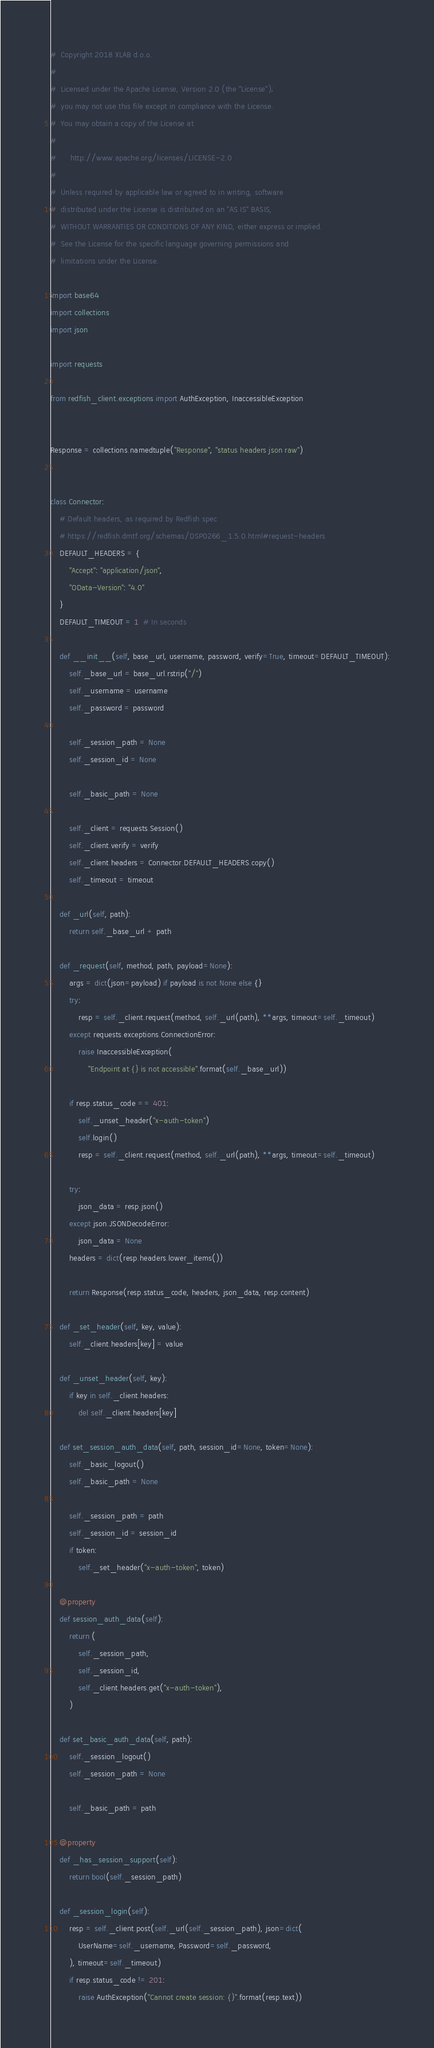<code> <loc_0><loc_0><loc_500><loc_500><_Python_>#  Copyright 2018 XLAB d.o.o.
#
#  Licensed under the Apache License, Version 2.0 (the "License");
#  you may not use this file except in compliance with the License.
#  You may obtain a copy of the License at
#
#      http://www.apache.org/licenses/LICENSE-2.0
#
#  Unless required by applicable law or agreed to in writing, software
#  distributed under the License is distributed on an "AS IS" BASIS,
#  WITHOUT WARRANTIES OR CONDITIONS OF ANY KIND, either express or implied.
#  See the License for the specific language governing permissions and
#  limitations under the License.

import base64
import collections
import json

import requests

from redfish_client.exceptions import AuthException, InaccessibleException


Response = collections.namedtuple("Response", "status headers json raw")


class Connector:
    # Default headers, as required by Redfish spec
    # https://redfish.dmtf.org/schemas/DSP0266_1.5.0.html#request-headers
    DEFAULT_HEADERS = {
        "Accept": "application/json",
        "OData-Version": "4.0"
    }
    DEFAULT_TIMEOUT = 1  # In seconds

    def __init__(self, base_url, username, password, verify=True, timeout=DEFAULT_TIMEOUT):
        self._base_url = base_url.rstrip("/")
        self._username = username
        self._password = password

        self._session_path = None
        self._session_id = None

        self._basic_path = None

        self._client = requests.Session()
        self._client.verify = verify
        self._client.headers = Connector.DEFAULT_HEADERS.copy()
        self._timeout = timeout

    def _url(self, path):
        return self._base_url + path

    def _request(self, method, path, payload=None):
        args = dict(json=payload) if payload is not None else {}
        try:
            resp = self._client.request(method, self._url(path), **args, timeout=self._timeout)
        except requests.exceptions.ConnectionError:
            raise InaccessibleException(
                "Endpoint at {} is not accessible".format(self._base_url))

        if resp.status_code == 401:
            self._unset_header("x-auth-token")
            self.login()
            resp = self._client.request(method, self._url(path), **args, timeout=self._timeout)

        try:
            json_data = resp.json()
        except json.JSONDecodeError:
            json_data = None
        headers = dict(resp.headers.lower_items())

        return Response(resp.status_code, headers, json_data, resp.content)

    def _set_header(self, key, value):
        self._client.headers[key] = value

    def _unset_header(self, key):
        if key in self._client.headers:
            del self._client.headers[key]

    def set_session_auth_data(self, path, session_id=None, token=None):
        self._basic_logout()
        self._basic_path = None

        self._session_path = path
        self._session_id = session_id
        if token:
            self._set_header("x-auth-token", token)

    @property
    def session_auth_data(self):
        return (
            self._session_path,
            self._session_id,
            self._client.headers.get("x-auth-token"),
        )

    def set_basic_auth_data(self, path):
        self._session_logout()
        self._session_path = None

        self._basic_path = path

    @property
    def _has_session_support(self):
        return bool(self._session_path)

    def _session_login(self):
        resp = self._client.post(self._url(self._session_path), json=dict(
            UserName=self._username, Password=self._password,
        ), timeout=self._timeout)
        if resp.status_code != 201:
            raise AuthException("Cannot create session: {}".format(resp.text))
</code> 